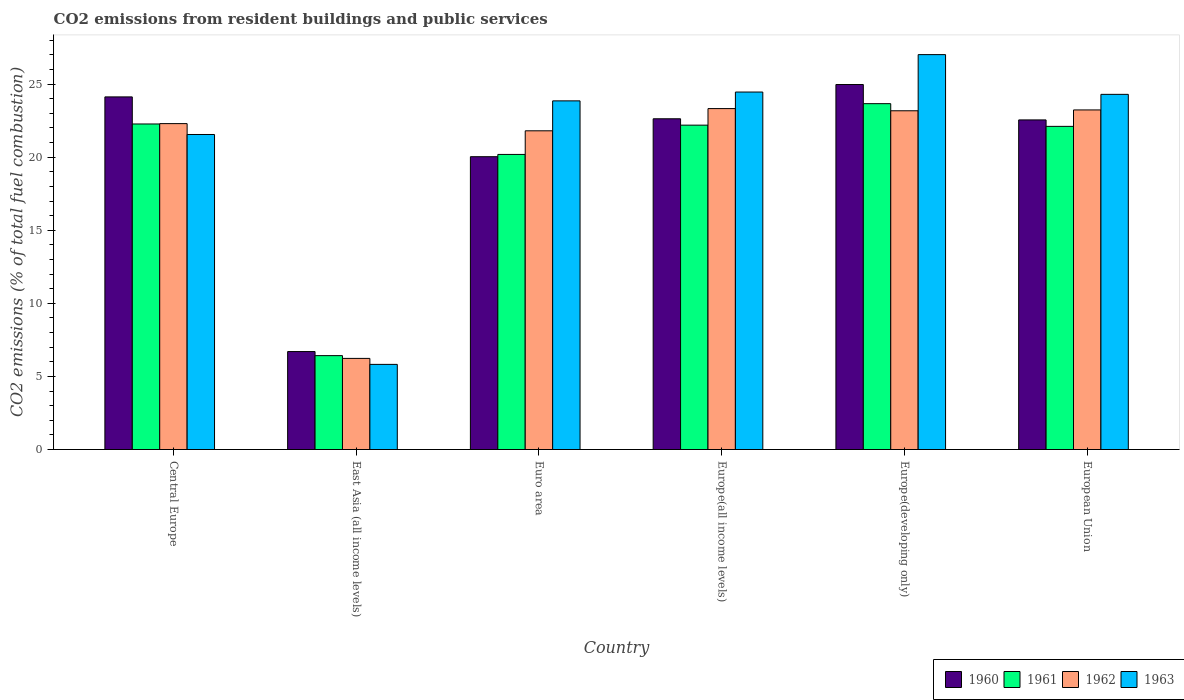How many bars are there on the 4th tick from the left?
Your answer should be compact. 4. What is the label of the 1st group of bars from the left?
Offer a very short reply. Central Europe. What is the total CO2 emitted in 1962 in Euro area?
Your answer should be compact. 21.8. Across all countries, what is the maximum total CO2 emitted in 1962?
Your answer should be compact. 23.32. Across all countries, what is the minimum total CO2 emitted in 1963?
Offer a very short reply. 5.82. In which country was the total CO2 emitted in 1961 maximum?
Your response must be concise. Europe(developing only). In which country was the total CO2 emitted in 1962 minimum?
Your answer should be very brief. East Asia (all income levels). What is the total total CO2 emitted in 1962 in the graph?
Your answer should be very brief. 120.06. What is the difference between the total CO2 emitted in 1960 in Europe(all income levels) and that in European Union?
Offer a terse response. 0.08. What is the difference between the total CO2 emitted in 1961 in European Union and the total CO2 emitted in 1963 in Europe(all income levels)?
Your answer should be compact. -2.35. What is the average total CO2 emitted in 1961 per country?
Ensure brevity in your answer.  19.47. What is the difference between the total CO2 emitted of/in 1963 and total CO2 emitted of/in 1960 in European Union?
Give a very brief answer. 1.75. What is the ratio of the total CO2 emitted in 1960 in Euro area to that in Europe(developing only)?
Your response must be concise. 0.8. Is the total CO2 emitted in 1963 in Europe(all income levels) less than that in European Union?
Provide a short and direct response. No. Is the difference between the total CO2 emitted in 1963 in East Asia (all income levels) and Europe(developing only) greater than the difference between the total CO2 emitted in 1960 in East Asia (all income levels) and Europe(developing only)?
Offer a terse response. No. What is the difference between the highest and the second highest total CO2 emitted in 1960?
Your response must be concise. 0.85. What is the difference between the highest and the lowest total CO2 emitted in 1962?
Provide a succinct answer. 17.09. In how many countries, is the total CO2 emitted in 1961 greater than the average total CO2 emitted in 1961 taken over all countries?
Provide a succinct answer. 5. Is the sum of the total CO2 emitted in 1962 in Central Europe and Europe(developing only) greater than the maximum total CO2 emitted in 1963 across all countries?
Give a very brief answer. Yes. What does the 2nd bar from the right in East Asia (all income levels) represents?
Give a very brief answer. 1962. How many bars are there?
Ensure brevity in your answer.  24. Are all the bars in the graph horizontal?
Make the answer very short. No. How many countries are there in the graph?
Offer a terse response. 6. How many legend labels are there?
Your response must be concise. 4. What is the title of the graph?
Ensure brevity in your answer.  CO2 emissions from resident buildings and public services. What is the label or title of the Y-axis?
Provide a short and direct response. CO2 emissions (% of total fuel combustion). What is the CO2 emissions (% of total fuel combustion) of 1960 in Central Europe?
Keep it short and to the point. 24.12. What is the CO2 emissions (% of total fuel combustion) of 1961 in Central Europe?
Provide a short and direct response. 22.27. What is the CO2 emissions (% of total fuel combustion) in 1962 in Central Europe?
Offer a terse response. 22.3. What is the CO2 emissions (% of total fuel combustion) of 1963 in Central Europe?
Your answer should be compact. 21.55. What is the CO2 emissions (% of total fuel combustion) in 1960 in East Asia (all income levels)?
Make the answer very short. 6.7. What is the CO2 emissions (% of total fuel combustion) of 1961 in East Asia (all income levels)?
Provide a short and direct response. 6.42. What is the CO2 emissions (% of total fuel combustion) in 1962 in East Asia (all income levels)?
Your answer should be compact. 6.23. What is the CO2 emissions (% of total fuel combustion) of 1963 in East Asia (all income levels)?
Give a very brief answer. 5.82. What is the CO2 emissions (% of total fuel combustion) of 1960 in Euro area?
Your response must be concise. 20.03. What is the CO2 emissions (% of total fuel combustion) of 1961 in Euro area?
Your response must be concise. 20.19. What is the CO2 emissions (% of total fuel combustion) of 1962 in Euro area?
Give a very brief answer. 21.8. What is the CO2 emissions (% of total fuel combustion) of 1963 in Euro area?
Make the answer very short. 23.85. What is the CO2 emissions (% of total fuel combustion) in 1960 in Europe(all income levels)?
Make the answer very short. 22.63. What is the CO2 emissions (% of total fuel combustion) of 1961 in Europe(all income levels)?
Your answer should be compact. 22.19. What is the CO2 emissions (% of total fuel combustion) of 1962 in Europe(all income levels)?
Offer a very short reply. 23.32. What is the CO2 emissions (% of total fuel combustion) in 1963 in Europe(all income levels)?
Give a very brief answer. 24.45. What is the CO2 emissions (% of total fuel combustion) of 1960 in Europe(developing only)?
Offer a very short reply. 24.97. What is the CO2 emissions (% of total fuel combustion) in 1961 in Europe(developing only)?
Offer a terse response. 23.66. What is the CO2 emissions (% of total fuel combustion) of 1962 in Europe(developing only)?
Give a very brief answer. 23.17. What is the CO2 emissions (% of total fuel combustion) of 1963 in Europe(developing only)?
Ensure brevity in your answer.  27.01. What is the CO2 emissions (% of total fuel combustion) of 1960 in European Union?
Your answer should be very brief. 22.55. What is the CO2 emissions (% of total fuel combustion) in 1961 in European Union?
Offer a terse response. 22.11. What is the CO2 emissions (% of total fuel combustion) of 1962 in European Union?
Provide a succinct answer. 23.23. What is the CO2 emissions (% of total fuel combustion) in 1963 in European Union?
Keep it short and to the point. 24.3. Across all countries, what is the maximum CO2 emissions (% of total fuel combustion) in 1960?
Make the answer very short. 24.97. Across all countries, what is the maximum CO2 emissions (% of total fuel combustion) in 1961?
Offer a very short reply. 23.66. Across all countries, what is the maximum CO2 emissions (% of total fuel combustion) of 1962?
Provide a short and direct response. 23.32. Across all countries, what is the maximum CO2 emissions (% of total fuel combustion) of 1963?
Provide a short and direct response. 27.01. Across all countries, what is the minimum CO2 emissions (% of total fuel combustion) of 1960?
Offer a terse response. 6.7. Across all countries, what is the minimum CO2 emissions (% of total fuel combustion) of 1961?
Ensure brevity in your answer.  6.42. Across all countries, what is the minimum CO2 emissions (% of total fuel combustion) of 1962?
Your answer should be very brief. 6.23. Across all countries, what is the minimum CO2 emissions (% of total fuel combustion) in 1963?
Offer a very short reply. 5.82. What is the total CO2 emissions (% of total fuel combustion) of 1960 in the graph?
Keep it short and to the point. 121. What is the total CO2 emissions (% of total fuel combustion) of 1961 in the graph?
Give a very brief answer. 116.84. What is the total CO2 emissions (% of total fuel combustion) in 1962 in the graph?
Ensure brevity in your answer.  120.06. What is the total CO2 emissions (% of total fuel combustion) in 1963 in the graph?
Your answer should be very brief. 126.99. What is the difference between the CO2 emissions (% of total fuel combustion) in 1960 in Central Europe and that in East Asia (all income levels)?
Your response must be concise. 17.42. What is the difference between the CO2 emissions (% of total fuel combustion) of 1961 in Central Europe and that in East Asia (all income levels)?
Your answer should be very brief. 15.85. What is the difference between the CO2 emissions (% of total fuel combustion) of 1962 in Central Europe and that in East Asia (all income levels)?
Provide a short and direct response. 16.06. What is the difference between the CO2 emissions (% of total fuel combustion) of 1963 in Central Europe and that in East Asia (all income levels)?
Your response must be concise. 15.73. What is the difference between the CO2 emissions (% of total fuel combustion) in 1960 in Central Europe and that in Euro area?
Provide a short and direct response. 4.09. What is the difference between the CO2 emissions (% of total fuel combustion) in 1961 in Central Europe and that in Euro area?
Your answer should be compact. 2.08. What is the difference between the CO2 emissions (% of total fuel combustion) in 1962 in Central Europe and that in Euro area?
Offer a very short reply. 0.49. What is the difference between the CO2 emissions (% of total fuel combustion) in 1963 in Central Europe and that in Euro area?
Your answer should be compact. -2.3. What is the difference between the CO2 emissions (% of total fuel combustion) of 1960 in Central Europe and that in Europe(all income levels)?
Offer a terse response. 1.5. What is the difference between the CO2 emissions (% of total fuel combustion) of 1961 in Central Europe and that in Europe(all income levels)?
Keep it short and to the point. 0.08. What is the difference between the CO2 emissions (% of total fuel combustion) in 1962 in Central Europe and that in Europe(all income levels)?
Provide a succinct answer. -1.03. What is the difference between the CO2 emissions (% of total fuel combustion) in 1963 in Central Europe and that in Europe(all income levels)?
Provide a succinct answer. -2.9. What is the difference between the CO2 emissions (% of total fuel combustion) of 1960 in Central Europe and that in Europe(developing only)?
Give a very brief answer. -0.85. What is the difference between the CO2 emissions (% of total fuel combustion) of 1961 in Central Europe and that in Europe(developing only)?
Make the answer very short. -1.39. What is the difference between the CO2 emissions (% of total fuel combustion) in 1962 in Central Europe and that in Europe(developing only)?
Your answer should be compact. -0.88. What is the difference between the CO2 emissions (% of total fuel combustion) of 1963 in Central Europe and that in Europe(developing only)?
Provide a succinct answer. -5.46. What is the difference between the CO2 emissions (% of total fuel combustion) in 1960 in Central Europe and that in European Union?
Ensure brevity in your answer.  1.57. What is the difference between the CO2 emissions (% of total fuel combustion) of 1961 in Central Europe and that in European Union?
Keep it short and to the point. 0.16. What is the difference between the CO2 emissions (% of total fuel combustion) of 1962 in Central Europe and that in European Union?
Offer a terse response. -0.94. What is the difference between the CO2 emissions (% of total fuel combustion) in 1963 in Central Europe and that in European Union?
Keep it short and to the point. -2.75. What is the difference between the CO2 emissions (% of total fuel combustion) of 1960 in East Asia (all income levels) and that in Euro area?
Provide a short and direct response. -13.33. What is the difference between the CO2 emissions (% of total fuel combustion) of 1961 in East Asia (all income levels) and that in Euro area?
Your response must be concise. -13.76. What is the difference between the CO2 emissions (% of total fuel combustion) of 1962 in East Asia (all income levels) and that in Euro area?
Provide a succinct answer. -15.57. What is the difference between the CO2 emissions (% of total fuel combustion) in 1963 in East Asia (all income levels) and that in Euro area?
Provide a succinct answer. -18.03. What is the difference between the CO2 emissions (% of total fuel combustion) in 1960 in East Asia (all income levels) and that in Europe(all income levels)?
Offer a very short reply. -15.92. What is the difference between the CO2 emissions (% of total fuel combustion) of 1961 in East Asia (all income levels) and that in Europe(all income levels)?
Your answer should be very brief. -15.77. What is the difference between the CO2 emissions (% of total fuel combustion) of 1962 in East Asia (all income levels) and that in Europe(all income levels)?
Your answer should be compact. -17.09. What is the difference between the CO2 emissions (% of total fuel combustion) in 1963 in East Asia (all income levels) and that in Europe(all income levels)?
Offer a very short reply. -18.63. What is the difference between the CO2 emissions (% of total fuel combustion) in 1960 in East Asia (all income levels) and that in Europe(developing only)?
Provide a short and direct response. -18.27. What is the difference between the CO2 emissions (% of total fuel combustion) in 1961 in East Asia (all income levels) and that in Europe(developing only)?
Offer a terse response. -17.24. What is the difference between the CO2 emissions (% of total fuel combustion) of 1962 in East Asia (all income levels) and that in Europe(developing only)?
Your answer should be compact. -16.94. What is the difference between the CO2 emissions (% of total fuel combustion) of 1963 in East Asia (all income levels) and that in Europe(developing only)?
Your response must be concise. -21.19. What is the difference between the CO2 emissions (% of total fuel combustion) in 1960 in East Asia (all income levels) and that in European Union?
Ensure brevity in your answer.  -15.85. What is the difference between the CO2 emissions (% of total fuel combustion) of 1961 in East Asia (all income levels) and that in European Union?
Keep it short and to the point. -15.68. What is the difference between the CO2 emissions (% of total fuel combustion) in 1962 in East Asia (all income levels) and that in European Union?
Offer a terse response. -17. What is the difference between the CO2 emissions (% of total fuel combustion) in 1963 in East Asia (all income levels) and that in European Union?
Offer a very short reply. -18.47. What is the difference between the CO2 emissions (% of total fuel combustion) of 1960 in Euro area and that in Europe(all income levels)?
Provide a short and direct response. -2.59. What is the difference between the CO2 emissions (% of total fuel combustion) of 1961 in Euro area and that in Europe(all income levels)?
Provide a short and direct response. -2. What is the difference between the CO2 emissions (% of total fuel combustion) of 1962 in Euro area and that in Europe(all income levels)?
Provide a succinct answer. -1.52. What is the difference between the CO2 emissions (% of total fuel combustion) of 1963 in Euro area and that in Europe(all income levels)?
Your answer should be compact. -0.6. What is the difference between the CO2 emissions (% of total fuel combustion) in 1960 in Euro area and that in Europe(developing only)?
Offer a very short reply. -4.94. What is the difference between the CO2 emissions (% of total fuel combustion) in 1961 in Euro area and that in Europe(developing only)?
Your answer should be compact. -3.47. What is the difference between the CO2 emissions (% of total fuel combustion) in 1962 in Euro area and that in Europe(developing only)?
Your response must be concise. -1.37. What is the difference between the CO2 emissions (% of total fuel combustion) in 1963 in Euro area and that in Europe(developing only)?
Offer a terse response. -3.16. What is the difference between the CO2 emissions (% of total fuel combustion) in 1960 in Euro area and that in European Union?
Your response must be concise. -2.52. What is the difference between the CO2 emissions (% of total fuel combustion) in 1961 in Euro area and that in European Union?
Provide a short and direct response. -1.92. What is the difference between the CO2 emissions (% of total fuel combustion) of 1962 in Euro area and that in European Union?
Make the answer very short. -1.43. What is the difference between the CO2 emissions (% of total fuel combustion) of 1963 in Euro area and that in European Union?
Make the answer very short. -0.45. What is the difference between the CO2 emissions (% of total fuel combustion) in 1960 in Europe(all income levels) and that in Europe(developing only)?
Make the answer very short. -2.34. What is the difference between the CO2 emissions (% of total fuel combustion) of 1961 in Europe(all income levels) and that in Europe(developing only)?
Keep it short and to the point. -1.47. What is the difference between the CO2 emissions (% of total fuel combustion) in 1962 in Europe(all income levels) and that in Europe(developing only)?
Make the answer very short. 0.15. What is the difference between the CO2 emissions (% of total fuel combustion) of 1963 in Europe(all income levels) and that in Europe(developing only)?
Your answer should be very brief. -2.56. What is the difference between the CO2 emissions (% of total fuel combustion) in 1960 in Europe(all income levels) and that in European Union?
Ensure brevity in your answer.  0.08. What is the difference between the CO2 emissions (% of total fuel combustion) of 1961 in Europe(all income levels) and that in European Union?
Offer a terse response. 0.08. What is the difference between the CO2 emissions (% of total fuel combustion) in 1962 in Europe(all income levels) and that in European Union?
Ensure brevity in your answer.  0.09. What is the difference between the CO2 emissions (% of total fuel combustion) in 1963 in Europe(all income levels) and that in European Union?
Ensure brevity in your answer.  0.16. What is the difference between the CO2 emissions (% of total fuel combustion) of 1960 in Europe(developing only) and that in European Union?
Keep it short and to the point. 2.42. What is the difference between the CO2 emissions (% of total fuel combustion) in 1961 in Europe(developing only) and that in European Union?
Provide a short and direct response. 1.55. What is the difference between the CO2 emissions (% of total fuel combustion) of 1962 in Europe(developing only) and that in European Union?
Your answer should be very brief. -0.06. What is the difference between the CO2 emissions (% of total fuel combustion) in 1963 in Europe(developing only) and that in European Union?
Ensure brevity in your answer.  2.72. What is the difference between the CO2 emissions (% of total fuel combustion) of 1960 in Central Europe and the CO2 emissions (% of total fuel combustion) of 1961 in East Asia (all income levels)?
Offer a terse response. 17.7. What is the difference between the CO2 emissions (% of total fuel combustion) of 1960 in Central Europe and the CO2 emissions (% of total fuel combustion) of 1962 in East Asia (all income levels)?
Your answer should be very brief. 17.89. What is the difference between the CO2 emissions (% of total fuel combustion) of 1960 in Central Europe and the CO2 emissions (% of total fuel combustion) of 1963 in East Asia (all income levels)?
Your response must be concise. 18.3. What is the difference between the CO2 emissions (% of total fuel combustion) in 1961 in Central Europe and the CO2 emissions (% of total fuel combustion) in 1962 in East Asia (all income levels)?
Keep it short and to the point. 16.04. What is the difference between the CO2 emissions (% of total fuel combustion) in 1961 in Central Europe and the CO2 emissions (% of total fuel combustion) in 1963 in East Asia (all income levels)?
Keep it short and to the point. 16.45. What is the difference between the CO2 emissions (% of total fuel combustion) in 1962 in Central Europe and the CO2 emissions (% of total fuel combustion) in 1963 in East Asia (all income levels)?
Keep it short and to the point. 16.47. What is the difference between the CO2 emissions (% of total fuel combustion) of 1960 in Central Europe and the CO2 emissions (% of total fuel combustion) of 1961 in Euro area?
Keep it short and to the point. 3.94. What is the difference between the CO2 emissions (% of total fuel combustion) of 1960 in Central Europe and the CO2 emissions (% of total fuel combustion) of 1962 in Euro area?
Provide a short and direct response. 2.32. What is the difference between the CO2 emissions (% of total fuel combustion) of 1960 in Central Europe and the CO2 emissions (% of total fuel combustion) of 1963 in Euro area?
Give a very brief answer. 0.27. What is the difference between the CO2 emissions (% of total fuel combustion) in 1961 in Central Europe and the CO2 emissions (% of total fuel combustion) in 1962 in Euro area?
Offer a very short reply. 0.47. What is the difference between the CO2 emissions (% of total fuel combustion) of 1961 in Central Europe and the CO2 emissions (% of total fuel combustion) of 1963 in Euro area?
Your answer should be very brief. -1.58. What is the difference between the CO2 emissions (% of total fuel combustion) in 1962 in Central Europe and the CO2 emissions (% of total fuel combustion) in 1963 in Euro area?
Make the answer very short. -1.56. What is the difference between the CO2 emissions (% of total fuel combustion) in 1960 in Central Europe and the CO2 emissions (% of total fuel combustion) in 1961 in Europe(all income levels)?
Offer a very short reply. 1.93. What is the difference between the CO2 emissions (% of total fuel combustion) in 1960 in Central Europe and the CO2 emissions (% of total fuel combustion) in 1962 in Europe(all income levels)?
Your answer should be compact. 0.8. What is the difference between the CO2 emissions (% of total fuel combustion) in 1960 in Central Europe and the CO2 emissions (% of total fuel combustion) in 1963 in Europe(all income levels)?
Keep it short and to the point. -0.33. What is the difference between the CO2 emissions (% of total fuel combustion) in 1961 in Central Europe and the CO2 emissions (% of total fuel combustion) in 1962 in Europe(all income levels)?
Your answer should be very brief. -1.05. What is the difference between the CO2 emissions (% of total fuel combustion) in 1961 in Central Europe and the CO2 emissions (% of total fuel combustion) in 1963 in Europe(all income levels)?
Your response must be concise. -2.18. What is the difference between the CO2 emissions (% of total fuel combustion) in 1962 in Central Europe and the CO2 emissions (% of total fuel combustion) in 1963 in Europe(all income levels)?
Provide a succinct answer. -2.16. What is the difference between the CO2 emissions (% of total fuel combustion) in 1960 in Central Europe and the CO2 emissions (% of total fuel combustion) in 1961 in Europe(developing only)?
Your answer should be very brief. 0.46. What is the difference between the CO2 emissions (% of total fuel combustion) in 1960 in Central Europe and the CO2 emissions (% of total fuel combustion) in 1962 in Europe(developing only)?
Your answer should be compact. 0.95. What is the difference between the CO2 emissions (% of total fuel combustion) of 1960 in Central Europe and the CO2 emissions (% of total fuel combustion) of 1963 in Europe(developing only)?
Your answer should be compact. -2.89. What is the difference between the CO2 emissions (% of total fuel combustion) of 1961 in Central Europe and the CO2 emissions (% of total fuel combustion) of 1962 in Europe(developing only)?
Provide a short and direct response. -0.9. What is the difference between the CO2 emissions (% of total fuel combustion) in 1961 in Central Europe and the CO2 emissions (% of total fuel combustion) in 1963 in Europe(developing only)?
Provide a short and direct response. -4.74. What is the difference between the CO2 emissions (% of total fuel combustion) of 1962 in Central Europe and the CO2 emissions (% of total fuel combustion) of 1963 in Europe(developing only)?
Your answer should be very brief. -4.72. What is the difference between the CO2 emissions (% of total fuel combustion) in 1960 in Central Europe and the CO2 emissions (% of total fuel combustion) in 1961 in European Union?
Your answer should be compact. 2.02. What is the difference between the CO2 emissions (% of total fuel combustion) of 1960 in Central Europe and the CO2 emissions (% of total fuel combustion) of 1962 in European Union?
Give a very brief answer. 0.89. What is the difference between the CO2 emissions (% of total fuel combustion) in 1960 in Central Europe and the CO2 emissions (% of total fuel combustion) in 1963 in European Union?
Provide a succinct answer. -0.17. What is the difference between the CO2 emissions (% of total fuel combustion) in 1961 in Central Europe and the CO2 emissions (% of total fuel combustion) in 1962 in European Union?
Provide a succinct answer. -0.96. What is the difference between the CO2 emissions (% of total fuel combustion) of 1961 in Central Europe and the CO2 emissions (% of total fuel combustion) of 1963 in European Union?
Provide a succinct answer. -2.03. What is the difference between the CO2 emissions (% of total fuel combustion) in 1962 in Central Europe and the CO2 emissions (% of total fuel combustion) in 1963 in European Union?
Offer a terse response. -2. What is the difference between the CO2 emissions (% of total fuel combustion) in 1960 in East Asia (all income levels) and the CO2 emissions (% of total fuel combustion) in 1961 in Euro area?
Make the answer very short. -13.48. What is the difference between the CO2 emissions (% of total fuel combustion) of 1960 in East Asia (all income levels) and the CO2 emissions (% of total fuel combustion) of 1962 in Euro area?
Provide a short and direct response. -15.1. What is the difference between the CO2 emissions (% of total fuel combustion) in 1960 in East Asia (all income levels) and the CO2 emissions (% of total fuel combustion) in 1963 in Euro area?
Provide a short and direct response. -17.15. What is the difference between the CO2 emissions (% of total fuel combustion) of 1961 in East Asia (all income levels) and the CO2 emissions (% of total fuel combustion) of 1962 in Euro area?
Make the answer very short. -15.38. What is the difference between the CO2 emissions (% of total fuel combustion) in 1961 in East Asia (all income levels) and the CO2 emissions (% of total fuel combustion) in 1963 in Euro area?
Ensure brevity in your answer.  -17.43. What is the difference between the CO2 emissions (% of total fuel combustion) of 1962 in East Asia (all income levels) and the CO2 emissions (% of total fuel combustion) of 1963 in Euro area?
Your answer should be very brief. -17.62. What is the difference between the CO2 emissions (% of total fuel combustion) of 1960 in East Asia (all income levels) and the CO2 emissions (% of total fuel combustion) of 1961 in Europe(all income levels)?
Give a very brief answer. -15.49. What is the difference between the CO2 emissions (% of total fuel combustion) of 1960 in East Asia (all income levels) and the CO2 emissions (% of total fuel combustion) of 1962 in Europe(all income levels)?
Offer a terse response. -16.62. What is the difference between the CO2 emissions (% of total fuel combustion) of 1960 in East Asia (all income levels) and the CO2 emissions (% of total fuel combustion) of 1963 in Europe(all income levels)?
Offer a terse response. -17.75. What is the difference between the CO2 emissions (% of total fuel combustion) in 1961 in East Asia (all income levels) and the CO2 emissions (% of total fuel combustion) in 1962 in Europe(all income levels)?
Your answer should be very brief. -16.9. What is the difference between the CO2 emissions (% of total fuel combustion) in 1961 in East Asia (all income levels) and the CO2 emissions (% of total fuel combustion) in 1963 in Europe(all income levels)?
Offer a terse response. -18.03. What is the difference between the CO2 emissions (% of total fuel combustion) in 1962 in East Asia (all income levels) and the CO2 emissions (% of total fuel combustion) in 1963 in Europe(all income levels)?
Keep it short and to the point. -18.22. What is the difference between the CO2 emissions (% of total fuel combustion) of 1960 in East Asia (all income levels) and the CO2 emissions (% of total fuel combustion) of 1961 in Europe(developing only)?
Your response must be concise. -16.96. What is the difference between the CO2 emissions (% of total fuel combustion) in 1960 in East Asia (all income levels) and the CO2 emissions (% of total fuel combustion) in 1962 in Europe(developing only)?
Give a very brief answer. -16.47. What is the difference between the CO2 emissions (% of total fuel combustion) of 1960 in East Asia (all income levels) and the CO2 emissions (% of total fuel combustion) of 1963 in Europe(developing only)?
Give a very brief answer. -20.31. What is the difference between the CO2 emissions (% of total fuel combustion) of 1961 in East Asia (all income levels) and the CO2 emissions (% of total fuel combustion) of 1962 in Europe(developing only)?
Your response must be concise. -16.75. What is the difference between the CO2 emissions (% of total fuel combustion) of 1961 in East Asia (all income levels) and the CO2 emissions (% of total fuel combustion) of 1963 in Europe(developing only)?
Offer a terse response. -20.59. What is the difference between the CO2 emissions (% of total fuel combustion) in 1962 in East Asia (all income levels) and the CO2 emissions (% of total fuel combustion) in 1963 in Europe(developing only)?
Ensure brevity in your answer.  -20.78. What is the difference between the CO2 emissions (% of total fuel combustion) in 1960 in East Asia (all income levels) and the CO2 emissions (% of total fuel combustion) in 1961 in European Union?
Provide a succinct answer. -15.4. What is the difference between the CO2 emissions (% of total fuel combustion) in 1960 in East Asia (all income levels) and the CO2 emissions (% of total fuel combustion) in 1962 in European Union?
Give a very brief answer. -16.53. What is the difference between the CO2 emissions (% of total fuel combustion) in 1960 in East Asia (all income levels) and the CO2 emissions (% of total fuel combustion) in 1963 in European Union?
Offer a terse response. -17.59. What is the difference between the CO2 emissions (% of total fuel combustion) of 1961 in East Asia (all income levels) and the CO2 emissions (% of total fuel combustion) of 1962 in European Union?
Ensure brevity in your answer.  -16.81. What is the difference between the CO2 emissions (% of total fuel combustion) of 1961 in East Asia (all income levels) and the CO2 emissions (% of total fuel combustion) of 1963 in European Union?
Offer a terse response. -17.87. What is the difference between the CO2 emissions (% of total fuel combustion) in 1962 in East Asia (all income levels) and the CO2 emissions (% of total fuel combustion) in 1963 in European Union?
Offer a very short reply. -18.06. What is the difference between the CO2 emissions (% of total fuel combustion) in 1960 in Euro area and the CO2 emissions (% of total fuel combustion) in 1961 in Europe(all income levels)?
Give a very brief answer. -2.16. What is the difference between the CO2 emissions (% of total fuel combustion) of 1960 in Euro area and the CO2 emissions (% of total fuel combustion) of 1962 in Europe(all income levels)?
Offer a terse response. -3.29. What is the difference between the CO2 emissions (% of total fuel combustion) in 1960 in Euro area and the CO2 emissions (% of total fuel combustion) in 1963 in Europe(all income levels)?
Your response must be concise. -4.42. What is the difference between the CO2 emissions (% of total fuel combustion) of 1961 in Euro area and the CO2 emissions (% of total fuel combustion) of 1962 in Europe(all income levels)?
Give a very brief answer. -3.14. What is the difference between the CO2 emissions (% of total fuel combustion) of 1961 in Euro area and the CO2 emissions (% of total fuel combustion) of 1963 in Europe(all income levels)?
Offer a very short reply. -4.27. What is the difference between the CO2 emissions (% of total fuel combustion) in 1962 in Euro area and the CO2 emissions (% of total fuel combustion) in 1963 in Europe(all income levels)?
Your answer should be compact. -2.65. What is the difference between the CO2 emissions (% of total fuel combustion) in 1960 in Euro area and the CO2 emissions (% of total fuel combustion) in 1961 in Europe(developing only)?
Offer a terse response. -3.63. What is the difference between the CO2 emissions (% of total fuel combustion) of 1960 in Euro area and the CO2 emissions (% of total fuel combustion) of 1962 in Europe(developing only)?
Offer a very short reply. -3.14. What is the difference between the CO2 emissions (% of total fuel combustion) in 1960 in Euro area and the CO2 emissions (% of total fuel combustion) in 1963 in Europe(developing only)?
Ensure brevity in your answer.  -6.98. What is the difference between the CO2 emissions (% of total fuel combustion) of 1961 in Euro area and the CO2 emissions (% of total fuel combustion) of 1962 in Europe(developing only)?
Ensure brevity in your answer.  -2.99. What is the difference between the CO2 emissions (% of total fuel combustion) of 1961 in Euro area and the CO2 emissions (% of total fuel combustion) of 1963 in Europe(developing only)?
Your response must be concise. -6.83. What is the difference between the CO2 emissions (% of total fuel combustion) in 1962 in Euro area and the CO2 emissions (% of total fuel combustion) in 1963 in Europe(developing only)?
Offer a terse response. -5.21. What is the difference between the CO2 emissions (% of total fuel combustion) in 1960 in Euro area and the CO2 emissions (% of total fuel combustion) in 1961 in European Union?
Your answer should be very brief. -2.07. What is the difference between the CO2 emissions (% of total fuel combustion) in 1960 in Euro area and the CO2 emissions (% of total fuel combustion) in 1962 in European Union?
Offer a very short reply. -3.2. What is the difference between the CO2 emissions (% of total fuel combustion) of 1960 in Euro area and the CO2 emissions (% of total fuel combustion) of 1963 in European Union?
Keep it short and to the point. -4.26. What is the difference between the CO2 emissions (% of total fuel combustion) in 1961 in Euro area and the CO2 emissions (% of total fuel combustion) in 1962 in European Union?
Your response must be concise. -3.04. What is the difference between the CO2 emissions (% of total fuel combustion) of 1961 in Euro area and the CO2 emissions (% of total fuel combustion) of 1963 in European Union?
Ensure brevity in your answer.  -4.11. What is the difference between the CO2 emissions (% of total fuel combustion) of 1962 in Euro area and the CO2 emissions (% of total fuel combustion) of 1963 in European Union?
Ensure brevity in your answer.  -2.49. What is the difference between the CO2 emissions (% of total fuel combustion) of 1960 in Europe(all income levels) and the CO2 emissions (% of total fuel combustion) of 1961 in Europe(developing only)?
Your response must be concise. -1.03. What is the difference between the CO2 emissions (% of total fuel combustion) of 1960 in Europe(all income levels) and the CO2 emissions (% of total fuel combustion) of 1962 in Europe(developing only)?
Offer a terse response. -0.55. What is the difference between the CO2 emissions (% of total fuel combustion) of 1960 in Europe(all income levels) and the CO2 emissions (% of total fuel combustion) of 1963 in Europe(developing only)?
Provide a short and direct response. -4.39. What is the difference between the CO2 emissions (% of total fuel combustion) in 1961 in Europe(all income levels) and the CO2 emissions (% of total fuel combustion) in 1962 in Europe(developing only)?
Provide a short and direct response. -0.98. What is the difference between the CO2 emissions (% of total fuel combustion) of 1961 in Europe(all income levels) and the CO2 emissions (% of total fuel combustion) of 1963 in Europe(developing only)?
Ensure brevity in your answer.  -4.82. What is the difference between the CO2 emissions (% of total fuel combustion) in 1962 in Europe(all income levels) and the CO2 emissions (% of total fuel combustion) in 1963 in Europe(developing only)?
Ensure brevity in your answer.  -3.69. What is the difference between the CO2 emissions (% of total fuel combustion) of 1960 in Europe(all income levels) and the CO2 emissions (% of total fuel combustion) of 1961 in European Union?
Provide a succinct answer. 0.52. What is the difference between the CO2 emissions (% of total fuel combustion) of 1960 in Europe(all income levels) and the CO2 emissions (% of total fuel combustion) of 1962 in European Union?
Give a very brief answer. -0.61. What is the difference between the CO2 emissions (% of total fuel combustion) in 1960 in Europe(all income levels) and the CO2 emissions (% of total fuel combustion) in 1963 in European Union?
Your answer should be compact. -1.67. What is the difference between the CO2 emissions (% of total fuel combustion) of 1961 in Europe(all income levels) and the CO2 emissions (% of total fuel combustion) of 1962 in European Union?
Your response must be concise. -1.04. What is the difference between the CO2 emissions (% of total fuel combustion) of 1961 in Europe(all income levels) and the CO2 emissions (% of total fuel combustion) of 1963 in European Union?
Offer a very short reply. -2.11. What is the difference between the CO2 emissions (% of total fuel combustion) of 1962 in Europe(all income levels) and the CO2 emissions (% of total fuel combustion) of 1963 in European Union?
Your answer should be compact. -0.97. What is the difference between the CO2 emissions (% of total fuel combustion) in 1960 in Europe(developing only) and the CO2 emissions (% of total fuel combustion) in 1961 in European Union?
Offer a very short reply. 2.86. What is the difference between the CO2 emissions (% of total fuel combustion) of 1960 in Europe(developing only) and the CO2 emissions (% of total fuel combustion) of 1962 in European Union?
Give a very brief answer. 1.74. What is the difference between the CO2 emissions (% of total fuel combustion) in 1960 in Europe(developing only) and the CO2 emissions (% of total fuel combustion) in 1963 in European Union?
Offer a terse response. 0.67. What is the difference between the CO2 emissions (% of total fuel combustion) of 1961 in Europe(developing only) and the CO2 emissions (% of total fuel combustion) of 1962 in European Union?
Offer a terse response. 0.43. What is the difference between the CO2 emissions (% of total fuel combustion) in 1961 in Europe(developing only) and the CO2 emissions (% of total fuel combustion) in 1963 in European Union?
Offer a very short reply. -0.64. What is the difference between the CO2 emissions (% of total fuel combustion) of 1962 in Europe(developing only) and the CO2 emissions (% of total fuel combustion) of 1963 in European Union?
Your answer should be very brief. -1.12. What is the average CO2 emissions (% of total fuel combustion) in 1960 per country?
Provide a short and direct response. 20.17. What is the average CO2 emissions (% of total fuel combustion) of 1961 per country?
Offer a very short reply. 19.47. What is the average CO2 emissions (% of total fuel combustion) in 1962 per country?
Offer a very short reply. 20.01. What is the average CO2 emissions (% of total fuel combustion) of 1963 per country?
Offer a terse response. 21.17. What is the difference between the CO2 emissions (% of total fuel combustion) in 1960 and CO2 emissions (% of total fuel combustion) in 1961 in Central Europe?
Your answer should be very brief. 1.85. What is the difference between the CO2 emissions (% of total fuel combustion) of 1960 and CO2 emissions (% of total fuel combustion) of 1962 in Central Europe?
Give a very brief answer. 1.83. What is the difference between the CO2 emissions (% of total fuel combustion) in 1960 and CO2 emissions (% of total fuel combustion) in 1963 in Central Europe?
Your response must be concise. 2.57. What is the difference between the CO2 emissions (% of total fuel combustion) of 1961 and CO2 emissions (% of total fuel combustion) of 1962 in Central Europe?
Make the answer very short. -0.02. What is the difference between the CO2 emissions (% of total fuel combustion) of 1961 and CO2 emissions (% of total fuel combustion) of 1963 in Central Europe?
Keep it short and to the point. 0.72. What is the difference between the CO2 emissions (% of total fuel combustion) in 1962 and CO2 emissions (% of total fuel combustion) in 1963 in Central Europe?
Provide a short and direct response. 0.74. What is the difference between the CO2 emissions (% of total fuel combustion) of 1960 and CO2 emissions (% of total fuel combustion) of 1961 in East Asia (all income levels)?
Offer a very short reply. 0.28. What is the difference between the CO2 emissions (% of total fuel combustion) in 1960 and CO2 emissions (% of total fuel combustion) in 1962 in East Asia (all income levels)?
Your answer should be very brief. 0.47. What is the difference between the CO2 emissions (% of total fuel combustion) of 1960 and CO2 emissions (% of total fuel combustion) of 1963 in East Asia (all income levels)?
Offer a terse response. 0.88. What is the difference between the CO2 emissions (% of total fuel combustion) of 1961 and CO2 emissions (% of total fuel combustion) of 1962 in East Asia (all income levels)?
Keep it short and to the point. 0.19. What is the difference between the CO2 emissions (% of total fuel combustion) of 1961 and CO2 emissions (% of total fuel combustion) of 1963 in East Asia (all income levels)?
Provide a succinct answer. 0.6. What is the difference between the CO2 emissions (% of total fuel combustion) of 1962 and CO2 emissions (% of total fuel combustion) of 1963 in East Asia (all income levels)?
Offer a very short reply. 0.41. What is the difference between the CO2 emissions (% of total fuel combustion) of 1960 and CO2 emissions (% of total fuel combustion) of 1961 in Euro area?
Ensure brevity in your answer.  -0.15. What is the difference between the CO2 emissions (% of total fuel combustion) in 1960 and CO2 emissions (% of total fuel combustion) in 1962 in Euro area?
Keep it short and to the point. -1.77. What is the difference between the CO2 emissions (% of total fuel combustion) of 1960 and CO2 emissions (% of total fuel combustion) of 1963 in Euro area?
Offer a very short reply. -3.82. What is the difference between the CO2 emissions (% of total fuel combustion) in 1961 and CO2 emissions (% of total fuel combustion) in 1962 in Euro area?
Offer a very short reply. -1.62. What is the difference between the CO2 emissions (% of total fuel combustion) of 1961 and CO2 emissions (% of total fuel combustion) of 1963 in Euro area?
Provide a succinct answer. -3.66. What is the difference between the CO2 emissions (% of total fuel combustion) of 1962 and CO2 emissions (% of total fuel combustion) of 1963 in Euro area?
Your response must be concise. -2.05. What is the difference between the CO2 emissions (% of total fuel combustion) in 1960 and CO2 emissions (% of total fuel combustion) in 1961 in Europe(all income levels)?
Offer a very short reply. 0.44. What is the difference between the CO2 emissions (% of total fuel combustion) in 1960 and CO2 emissions (% of total fuel combustion) in 1962 in Europe(all income levels)?
Make the answer very short. -0.7. What is the difference between the CO2 emissions (% of total fuel combustion) of 1960 and CO2 emissions (% of total fuel combustion) of 1963 in Europe(all income levels)?
Provide a short and direct response. -1.83. What is the difference between the CO2 emissions (% of total fuel combustion) of 1961 and CO2 emissions (% of total fuel combustion) of 1962 in Europe(all income levels)?
Make the answer very short. -1.13. What is the difference between the CO2 emissions (% of total fuel combustion) of 1961 and CO2 emissions (% of total fuel combustion) of 1963 in Europe(all income levels)?
Your answer should be very brief. -2.26. What is the difference between the CO2 emissions (% of total fuel combustion) of 1962 and CO2 emissions (% of total fuel combustion) of 1963 in Europe(all income levels)?
Keep it short and to the point. -1.13. What is the difference between the CO2 emissions (% of total fuel combustion) of 1960 and CO2 emissions (% of total fuel combustion) of 1961 in Europe(developing only)?
Keep it short and to the point. 1.31. What is the difference between the CO2 emissions (% of total fuel combustion) in 1960 and CO2 emissions (% of total fuel combustion) in 1962 in Europe(developing only)?
Give a very brief answer. 1.8. What is the difference between the CO2 emissions (% of total fuel combustion) in 1960 and CO2 emissions (% of total fuel combustion) in 1963 in Europe(developing only)?
Your answer should be compact. -2.05. What is the difference between the CO2 emissions (% of total fuel combustion) of 1961 and CO2 emissions (% of total fuel combustion) of 1962 in Europe(developing only)?
Offer a terse response. 0.49. What is the difference between the CO2 emissions (% of total fuel combustion) in 1961 and CO2 emissions (% of total fuel combustion) in 1963 in Europe(developing only)?
Offer a terse response. -3.35. What is the difference between the CO2 emissions (% of total fuel combustion) in 1962 and CO2 emissions (% of total fuel combustion) in 1963 in Europe(developing only)?
Provide a short and direct response. -3.84. What is the difference between the CO2 emissions (% of total fuel combustion) of 1960 and CO2 emissions (% of total fuel combustion) of 1961 in European Union?
Give a very brief answer. 0.44. What is the difference between the CO2 emissions (% of total fuel combustion) in 1960 and CO2 emissions (% of total fuel combustion) in 1962 in European Union?
Give a very brief answer. -0.68. What is the difference between the CO2 emissions (% of total fuel combustion) in 1960 and CO2 emissions (% of total fuel combustion) in 1963 in European Union?
Give a very brief answer. -1.75. What is the difference between the CO2 emissions (% of total fuel combustion) of 1961 and CO2 emissions (% of total fuel combustion) of 1962 in European Union?
Your response must be concise. -1.13. What is the difference between the CO2 emissions (% of total fuel combustion) in 1961 and CO2 emissions (% of total fuel combustion) in 1963 in European Union?
Offer a very short reply. -2.19. What is the difference between the CO2 emissions (% of total fuel combustion) of 1962 and CO2 emissions (% of total fuel combustion) of 1963 in European Union?
Offer a very short reply. -1.07. What is the ratio of the CO2 emissions (% of total fuel combustion) in 1960 in Central Europe to that in East Asia (all income levels)?
Give a very brief answer. 3.6. What is the ratio of the CO2 emissions (% of total fuel combustion) in 1961 in Central Europe to that in East Asia (all income levels)?
Provide a succinct answer. 3.47. What is the ratio of the CO2 emissions (% of total fuel combustion) of 1962 in Central Europe to that in East Asia (all income levels)?
Provide a succinct answer. 3.58. What is the ratio of the CO2 emissions (% of total fuel combustion) of 1963 in Central Europe to that in East Asia (all income levels)?
Your answer should be compact. 3.7. What is the ratio of the CO2 emissions (% of total fuel combustion) in 1960 in Central Europe to that in Euro area?
Your answer should be very brief. 1.2. What is the ratio of the CO2 emissions (% of total fuel combustion) in 1961 in Central Europe to that in Euro area?
Give a very brief answer. 1.1. What is the ratio of the CO2 emissions (% of total fuel combustion) in 1962 in Central Europe to that in Euro area?
Provide a short and direct response. 1.02. What is the ratio of the CO2 emissions (% of total fuel combustion) in 1963 in Central Europe to that in Euro area?
Provide a short and direct response. 0.9. What is the ratio of the CO2 emissions (% of total fuel combustion) in 1960 in Central Europe to that in Europe(all income levels)?
Your answer should be compact. 1.07. What is the ratio of the CO2 emissions (% of total fuel combustion) of 1961 in Central Europe to that in Europe(all income levels)?
Provide a succinct answer. 1. What is the ratio of the CO2 emissions (% of total fuel combustion) of 1962 in Central Europe to that in Europe(all income levels)?
Offer a very short reply. 0.96. What is the ratio of the CO2 emissions (% of total fuel combustion) of 1963 in Central Europe to that in Europe(all income levels)?
Your response must be concise. 0.88. What is the ratio of the CO2 emissions (% of total fuel combustion) of 1960 in Central Europe to that in Europe(developing only)?
Ensure brevity in your answer.  0.97. What is the ratio of the CO2 emissions (% of total fuel combustion) of 1961 in Central Europe to that in Europe(developing only)?
Provide a short and direct response. 0.94. What is the ratio of the CO2 emissions (% of total fuel combustion) in 1962 in Central Europe to that in Europe(developing only)?
Your answer should be very brief. 0.96. What is the ratio of the CO2 emissions (% of total fuel combustion) in 1963 in Central Europe to that in Europe(developing only)?
Your answer should be compact. 0.8. What is the ratio of the CO2 emissions (% of total fuel combustion) in 1960 in Central Europe to that in European Union?
Your response must be concise. 1.07. What is the ratio of the CO2 emissions (% of total fuel combustion) of 1961 in Central Europe to that in European Union?
Give a very brief answer. 1.01. What is the ratio of the CO2 emissions (% of total fuel combustion) of 1962 in Central Europe to that in European Union?
Provide a succinct answer. 0.96. What is the ratio of the CO2 emissions (% of total fuel combustion) of 1963 in Central Europe to that in European Union?
Provide a short and direct response. 0.89. What is the ratio of the CO2 emissions (% of total fuel combustion) of 1960 in East Asia (all income levels) to that in Euro area?
Your answer should be compact. 0.33. What is the ratio of the CO2 emissions (% of total fuel combustion) in 1961 in East Asia (all income levels) to that in Euro area?
Offer a very short reply. 0.32. What is the ratio of the CO2 emissions (% of total fuel combustion) of 1962 in East Asia (all income levels) to that in Euro area?
Give a very brief answer. 0.29. What is the ratio of the CO2 emissions (% of total fuel combustion) of 1963 in East Asia (all income levels) to that in Euro area?
Offer a terse response. 0.24. What is the ratio of the CO2 emissions (% of total fuel combustion) of 1960 in East Asia (all income levels) to that in Europe(all income levels)?
Your response must be concise. 0.3. What is the ratio of the CO2 emissions (% of total fuel combustion) of 1961 in East Asia (all income levels) to that in Europe(all income levels)?
Keep it short and to the point. 0.29. What is the ratio of the CO2 emissions (% of total fuel combustion) in 1962 in East Asia (all income levels) to that in Europe(all income levels)?
Your answer should be very brief. 0.27. What is the ratio of the CO2 emissions (% of total fuel combustion) in 1963 in East Asia (all income levels) to that in Europe(all income levels)?
Your response must be concise. 0.24. What is the ratio of the CO2 emissions (% of total fuel combustion) of 1960 in East Asia (all income levels) to that in Europe(developing only)?
Your response must be concise. 0.27. What is the ratio of the CO2 emissions (% of total fuel combustion) in 1961 in East Asia (all income levels) to that in Europe(developing only)?
Ensure brevity in your answer.  0.27. What is the ratio of the CO2 emissions (% of total fuel combustion) of 1962 in East Asia (all income levels) to that in Europe(developing only)?
Your answer should be compact. 0.27. What is the ratio of the CO2 emissions (% of total fuel combustion) in 1963 in East Asia (all income levels) to that in Europe(developing only)?
Provide a succinct answer. 0.22. What is the ratio of the CO2 emissions (% of total fuel combustion) of 1960 in East Asia (all income levels) to that in European Union?
Keep it short and to the point. 0.3. What is the ratio of the CO2 emissions (% of total fuel combustion) of 1961 in East Asia (all income levels) to that in European Union?
Make the answer very short. 0.29. What is the ratio of the CO2 emissions (% of total fuel combustion) of 1962 in East Asia (all income levels) to that in European Union?
Your response must be concise. 0.27. What is the ratio of the CO2 emissions (% of total fuel combustion) in 1963 in East Asia (all income levels) to that in European Union?
Provide a short and direct response. 0.24. What is the ratio of the CO2 emissions (% of total fuel combustion) of 1960 in Euro area to that in Europe(all income levels)?
Offer a terse response. 0.89. What is the ratio of the CO2 emissions (% of total fuel combustion) in 1961 in Euro area to that in Europe(all income levels)?
Keep it short and to the point. 0.91. What is the ratio of the CO2 emissions (% of total fuel combustion) of 1962 in Euro area to that in Europe(all income levels)?
Your answer should be very brief. 0.93. What is the ratio of the CO2 emissions (% of total fuel combustion) of 1963 in Euro area to that in Europe(all income levels)?
Your answer should be compact. 0.98. What is the ratio of the CO2 emissions (% of total fuel combustion) in 1960 in Euro area to that in Europe(developing only)?
Ensure brevity in your answer.  0.8. What is the ratio of the CO2 emissions (% of total fuel combustion) in 1961 in Euro area to that in Europe(developing only)?
Your answer should be very brief. 0.85. What is the ratio of the CO2 emissions (% of total fuel combustion) in 1962 in Euro area to that in Europe(developing only)?
Give a very brief answer. 0.94. What is the ratio of the CO2 emissions (% of total fuel combustion) in 1963 in Euro area to that in Europe(developing only)?
Ensure brevity in your answer.  0.88. What is the ratio of the CO2 emissions (% of total fuel combustion) of 1960 in Euro area to that in European Union?
Offer a terse response. 0.89. What is the ratio of the CO2 emissions (% of total fuel combustion) in 1961 in Euro area to that in European Union?
Ensure brevity in your answer.  0.91. What is the ratio of the CO2 emissions (% of total fuel combustion) in 1962 in Euro area to that in European Union?
Make the answer very short. 0.94. What is the ratio of the CO2 emissions (% of total fuel combustion) of 1963 in Euro area to that in European Union?
Provide a short and direct response. 0.98. What is the ratio of the CO2 emissions (% of total fuel combustion) of 1960 in Europe(all income levels) to that in Europe(developing only)?
Offer a terse response. 0.91. What is the ratio of the CO2 emissions (% of total fuel combustion) in 1961 in Europe(all income levels) to that in Europe(developing only)?
Your response must be concise. 0.94. What is the ratio of the CO2 emissions (% of total fuel combustion) of 1963 in Europe(all income levels) to that in Europe(developing only)?
Provide a short and direct response. 0.91. What is the ratio of the CO2 emissions (% of total fuel combustion) of 1960 in Europe(all income levels) to that in European Union?
Ensure brevity in your answer.  1. What is the ratio of the CO2 emissions (% of total fuel combustion) in 1963 in Europe(all income levels) to that in European Union?
Offer a terse response. 1.01. What is the ratio of the CO2 emissions (% of total fuel combustion) in 1960 in Europe(developing only) to that in European Union?
Provide a short and direct response. 1.11. What is the ratio of the CO2 emissions (% of total fuel combustion) in 1961 in Europe(developing only) to that in European Union?
Your answer should be very brief. 1.07. What is the ratio of the CO2 emissions (% of total fuel combustion) of 1963 in Europe(developing only) to that in European Union?
Ensure brevity in your answer.  1.11. What is the difference between the highest and the second highest CO2 emissions (% of total fuel combustion) in 1960?
Your answer should be very brief. 0.85. What is the difference between the highest and the second highest CO2 emissions (% of total fuel combustion) in 1961?
Provide a succinct answer. 1.39. What is the difference between the highest and the second highest CO2 emissions (% of total fuel combustion) of 1962?
Make the answer very short. 0.09. What is the difference between the highest and the second highest CO2 emissions (% of total fuel combustion) in 1963?
Your response must be concise. 2.56. What is the difference between the highest and the lowest CO2 emissions (% of total fuel combustion) in 1960?
Make the answer very short. 18.27. What is the difference between the highest and the lowest CO2 emissions (% of total fuel combustion) in 1961?
Make the answer very short. 17.24. What is the difference between the highest and the lowest CO2 emissions (% of total fuel combustion) of 1962?
Your answer should be compact. 17.09. What is the difference between the highest and the lowest CO2 emissions (% of total fuel combustion) in 1963?
Give a very brief answer. 21.19. 